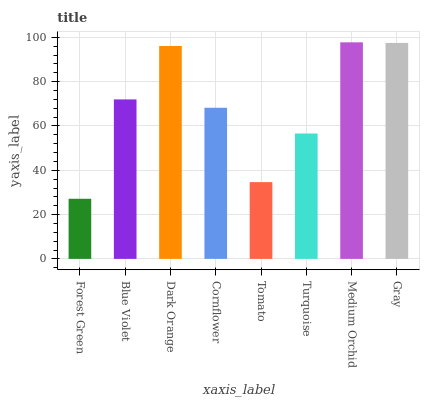Is Forest Green the minimum?
Answer yes or no. Yes. Is Medium Orchid the maximum?
Answer yes or no. Yes. Is Blue Violet the minimum?
Answer yes or no. No. Is Blue Violet the maximum?
Answer yes or no. No. Is Blue Violet greater than Forest Green?
Answer yes or no. Yes. Is Forest Green less than Blue Violet?
Answer yes or no. Yes. Is Forest Green greater than Blue Violet?
Answer yes or no. No. Is Blue Violet less than Forest Green?
Answer yes or no. No. Is Blue Violet the high median?
Answer yes or no. Yes. Is Cornflower the low median?
Answer yes or no. Yes. Is Medium Orchid the high median?
Answer yes or no. No. Is Tomato the low median?
Answer yes or no. No. 